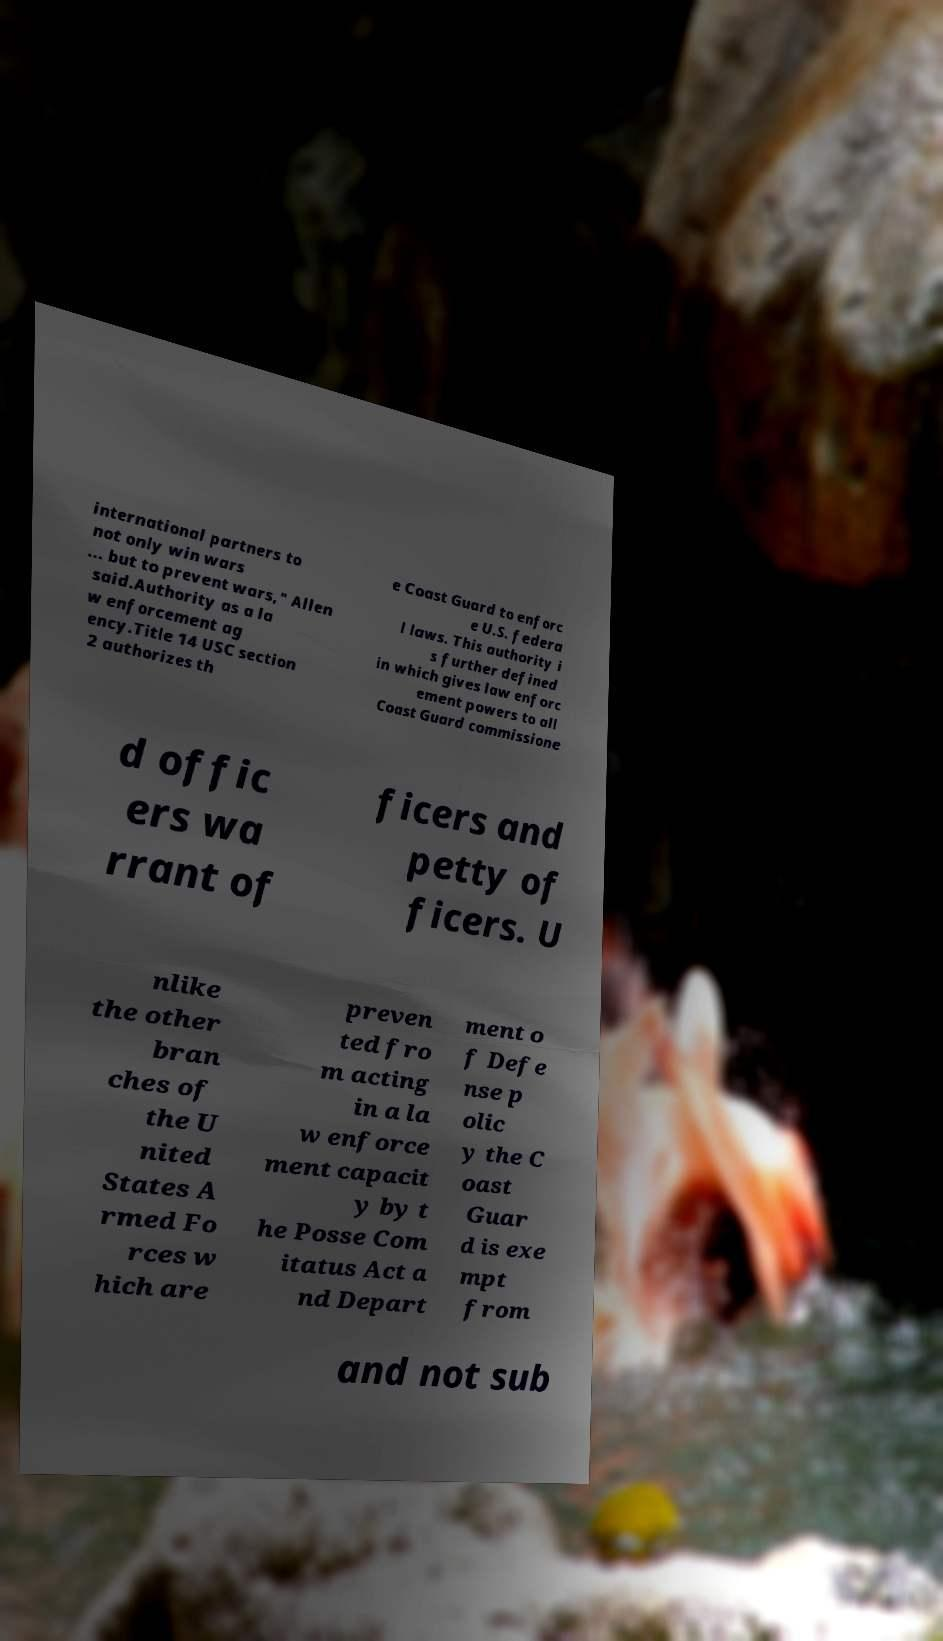Can you read and provide the text displayed in the image?This photo seems to have some interesting text. Can you extract and type it out for me? international partners to not only win wars ... but to prevent wars," Allen said.Authority as a la w enforcement ag ency.Title 14 USC section 2 authorizes th e Coast Guard to enforc e U.S. federa l laws. This authority i s further defined in which gives law enforc ement powers to all Coast Guard commissione d offic ers wa rrant of ficers and petty of ficers. U nlike the other bran ches of the U nited States A rmed Fo rces w hich are preven ted fro m acting in a la w enforce ment capacit y by t he Posse Com itatus Act a nd Depart ment o f Defe nse p olic y the C oast Guar d is exe mpt from and not sub 